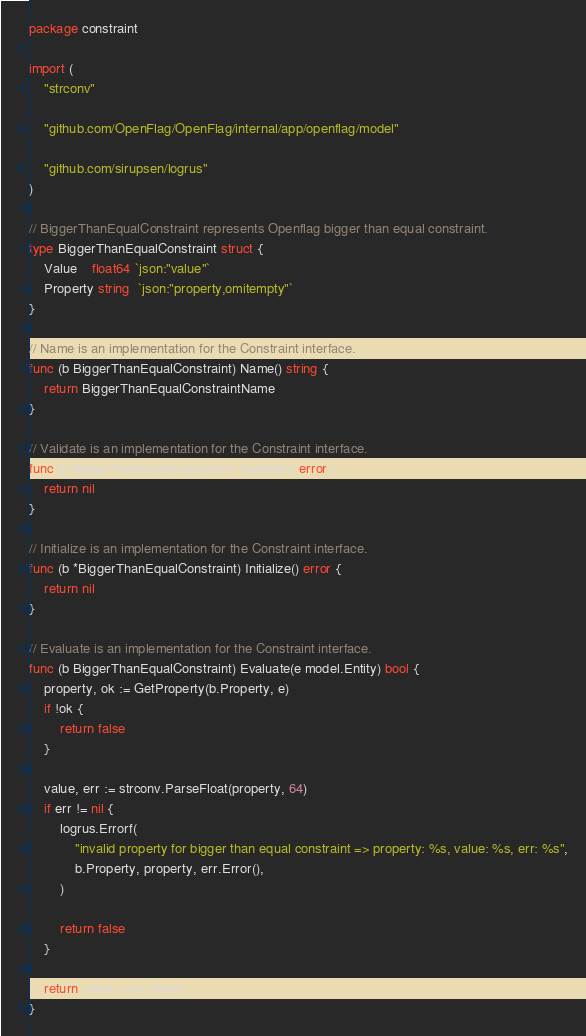Convert code to text. <code><loc_0><loc_0><loc_500><loc_500><_Go_>package constraint

import (
	"strconv"

	"github.com/OpenFlag/OpenFlag/internal/app/openflag/model"

	"github.com/sirupsen/logrus"
)

// BiggerThanEqualConstraint represents Openflag bigger than equal constraint.
type BiggerThanEqualConstraint struct {
	Value    float64 `json:"value"`
	Property string  `json:"property,omitempty"`
}

// Name is an implementation for the Constraint interface.
func (b BiggerThanEqualConstraint) Name() string {
	return BiggerThanEqualConstraintName
}

// Validate is an implementation for the Constraint interface.
func (b BiggerThanEqualConstraint) Validate() error {
	return nil
}

// Initialize is an implementation for the Constraint interface.
func (b *BiggerThanEqualConstraint) Initialize() error {
	return nil
}

// Evaluate is an implementation for the Constraint interface.
func (b BiggerThanEqualConstraint) Evaluate(e model.Entity) bool {
	property, ok := GetProperty(b.Property, e)
	if !ok {
		return false
	}

	value, err := strconv.ParseFloat(property, 64)
	if err != nil {
		logrus.Errorf(
			"invalid property for bigger than equal constraint => property: %s, value: %s, err: %s",
			b.Property, property, err.Error(),
		)

		return false
	}

	return value >= b.Value
}
</code> 